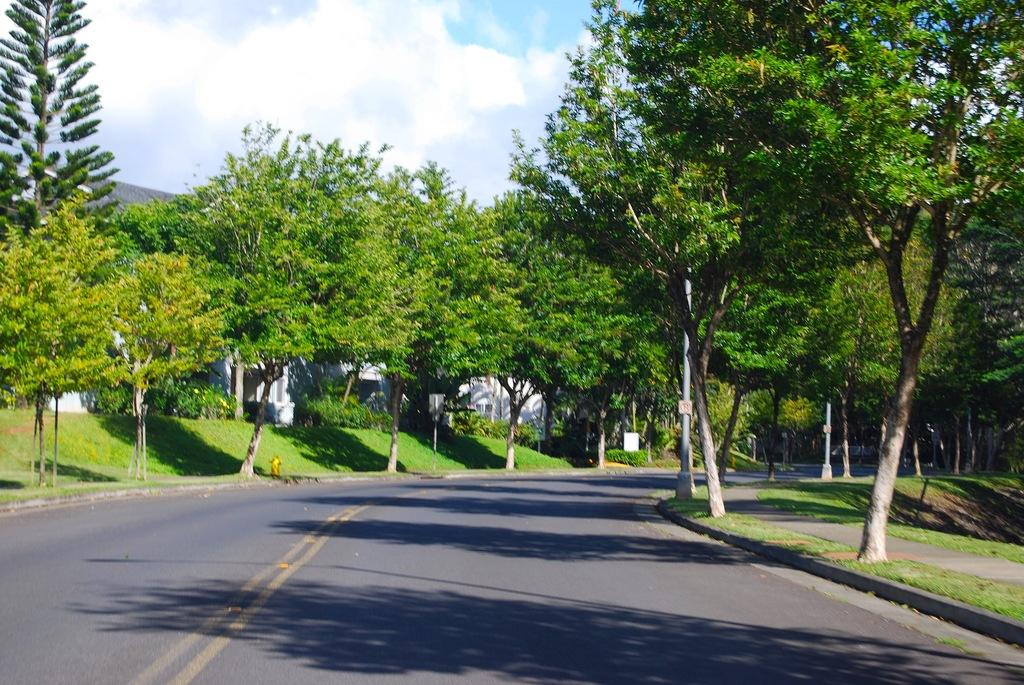What can be seen in the center of the image? The sky is visible in the center of the image. What is present in the sky? Clouds are present in the image. What type of structure can be seen in the image? There is at least one building in the image. What type of vegetation is present in the image? Trees, plants, and grass are visible in the image. What type of vertical structures are present in the image? Poles are visible in the image. What type of pathway is present in the image? A road is present in the image. Are there any other objects visible in the image? There are a few other indefinite objects in the image. What type of wood can be smelled in the image? There is no wood present in the image, and therefore no smell can be associated with it. What type of secretary is visible in the image? There is no secretary present in the image. 